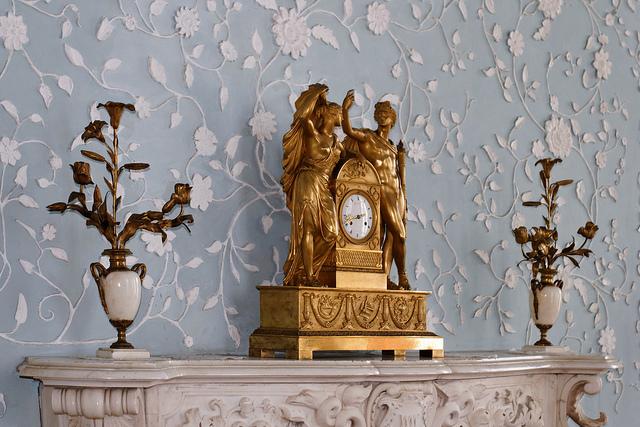What color is the clock statue?
Keep it brief. Gold. What is on the walls?
Keep it brief. Flowers. Is the clock plain?
Answer briefly. No. 